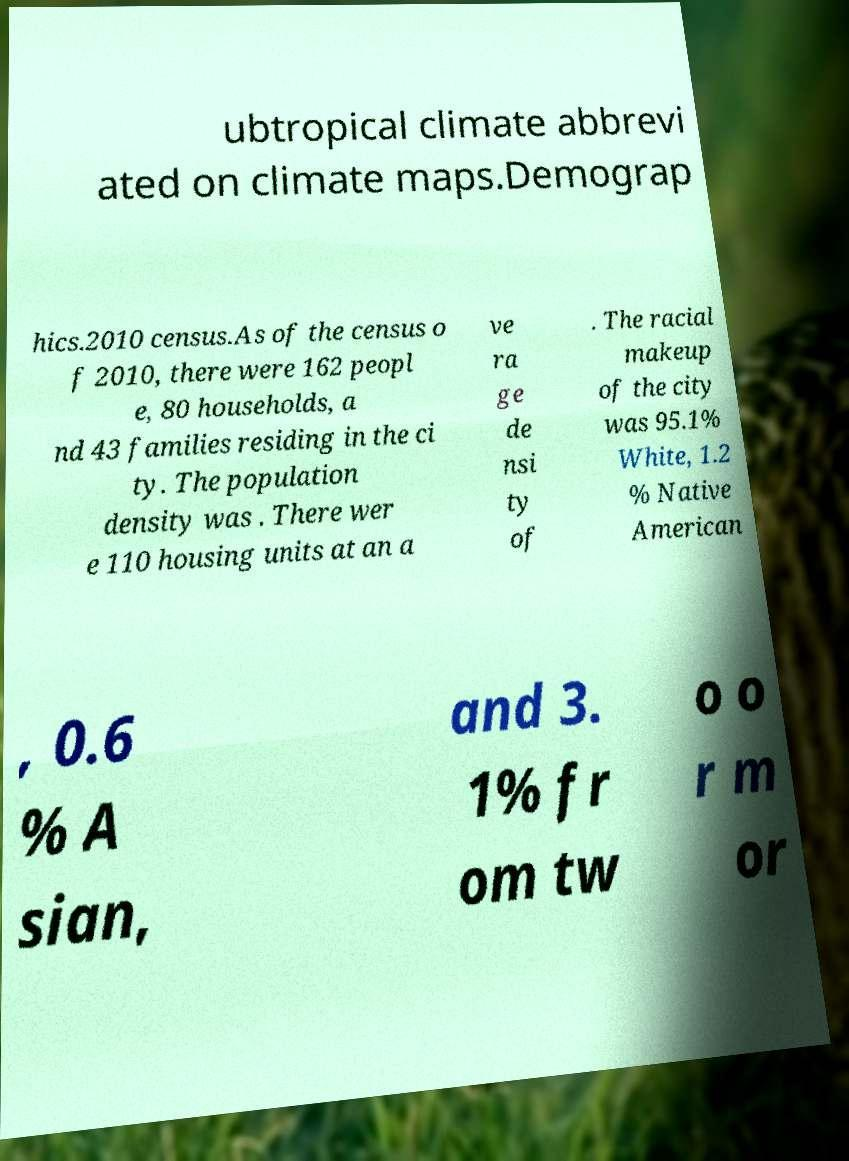Can you read and provide the text displayed in the image?This photo seems to have some interesting text. Can you extract and type it out for me? ubtropical climate abbrevi ated on climate maps.Demograp hics.2010 census.As of the census o f 2010, there were 162 peopl e, 80 households, a nd 43 families residing in the ci ty. The population density was . There wer e 110 housing units at an a ve ra ge de nsi ty of . The racial makeup of the city was 95.1% White, 1.2 % Native American , 0.6 % A sian, and 3. 1% fr om tw o o r m or 